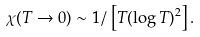<formula> <loc_0><loc_0><loc_500><loc_500>\chi ( T \to 0 ) \sim 1 / \left [ T ( \log T ) ^ { 2 } \right ] .</formula> 